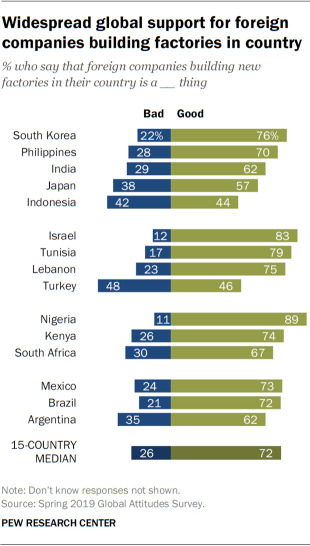List a handful of essential elements in this visual. The ratio of bad to good in the median data of 15 countries is 0.3611111111111111... The chart shows data from 15 countries. 